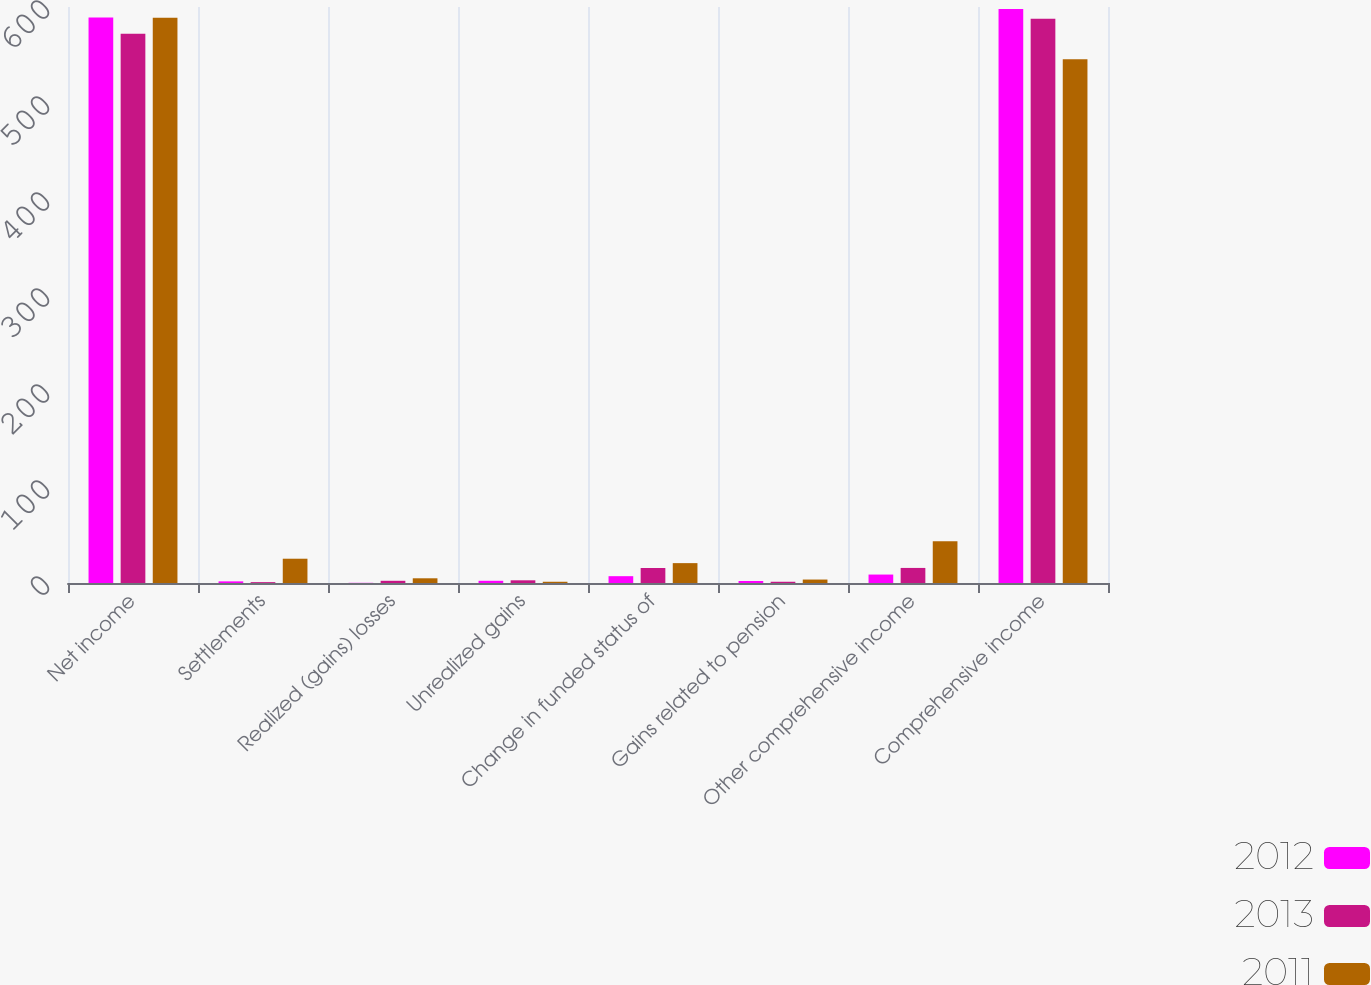Convert chart to OTSL. <chart><loc_0><loc_0><loc_500><loc_500><stacked_bar_chart><ecel><fcel>Net income<fcel>Settlements<fcel>Realized (gains) losses<fcel>Unrealized gains<fcel>Change in funded status of<fcel>Gains related to pension<fcel>Other comprehensive income<fcel>Comprehensive income<nl><fcel>2012<fcel>589.1<fcel>1.7<fcel>0.2<fcel>2.3<fcel>7.1<fcel>2.1<fcel>8.8<fcel>597.9<nl><fcel>2013<fcel>572.1<fcel>0.9<fcel>2.3<fcel>2.8<fcel>15.6<fcel>1.3<fcel>15.7<fcel>587.8<nl><fcel>2011<fcel>588.9<fcel>25.3<fcel>4.9<fcel>1.3<fcel>20.7<fcel>3.6<fcel>43.4<fcel>545.5<nl></chart> 